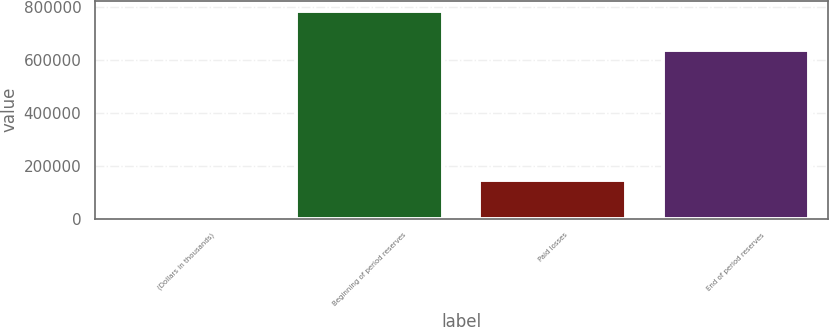<chart> <loc_0><loc_0><loc_500><loc_500><bar_chart><fcel>(Dollars in thousands)<fcel>Beginning of period reserves<fcel>Paid losses<fcel>End of period reserves<nl><fcel>2009<fcel>786843<fcel>148169<fcel>638674<nl></chart> 